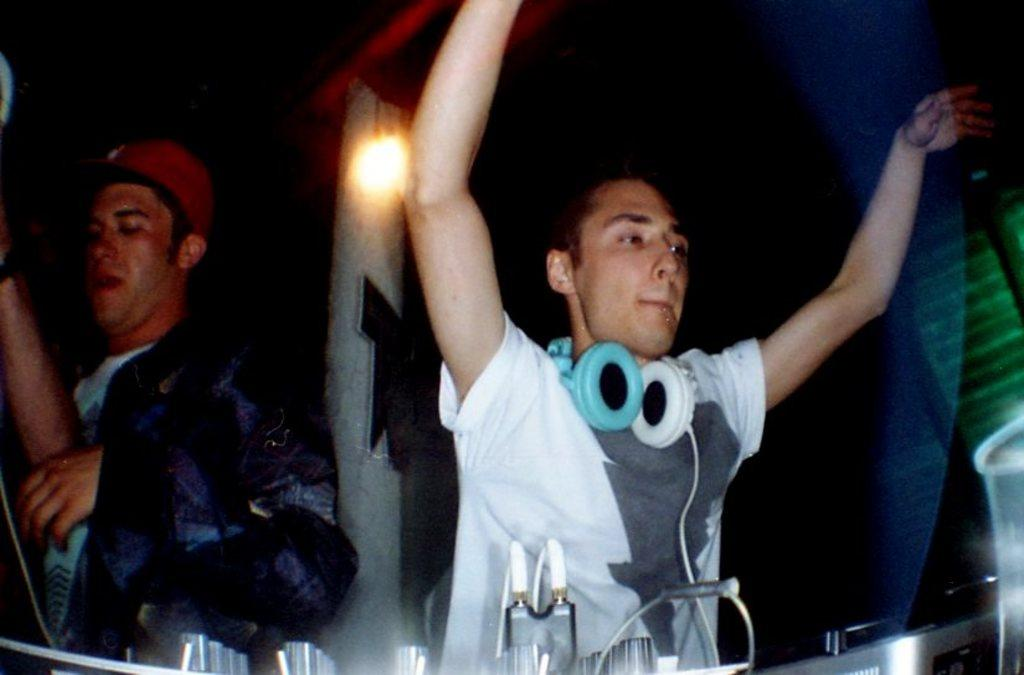Who or what is present in the image? There are people in the image. What can be seen in the image besides the people? There is a music rack system in the image. Is there any source of illumination visible in the image? Yes, there is a light in the image. How many passengers are waiting at the gate in the image? There is no reference to a gate or passengers in the image, so it's not possible to answer that question. 